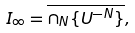<formula> <loc_0><loc_0><loc_500><loc_500>I _ { \infty } = \overline { \cap _ { N } \{ U ^ { - N } \} } ,</formula> 